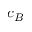Convert formula to latex. <formula><loc_0><loc_0><loc_500><loc_500>c _ { B }</formula> 